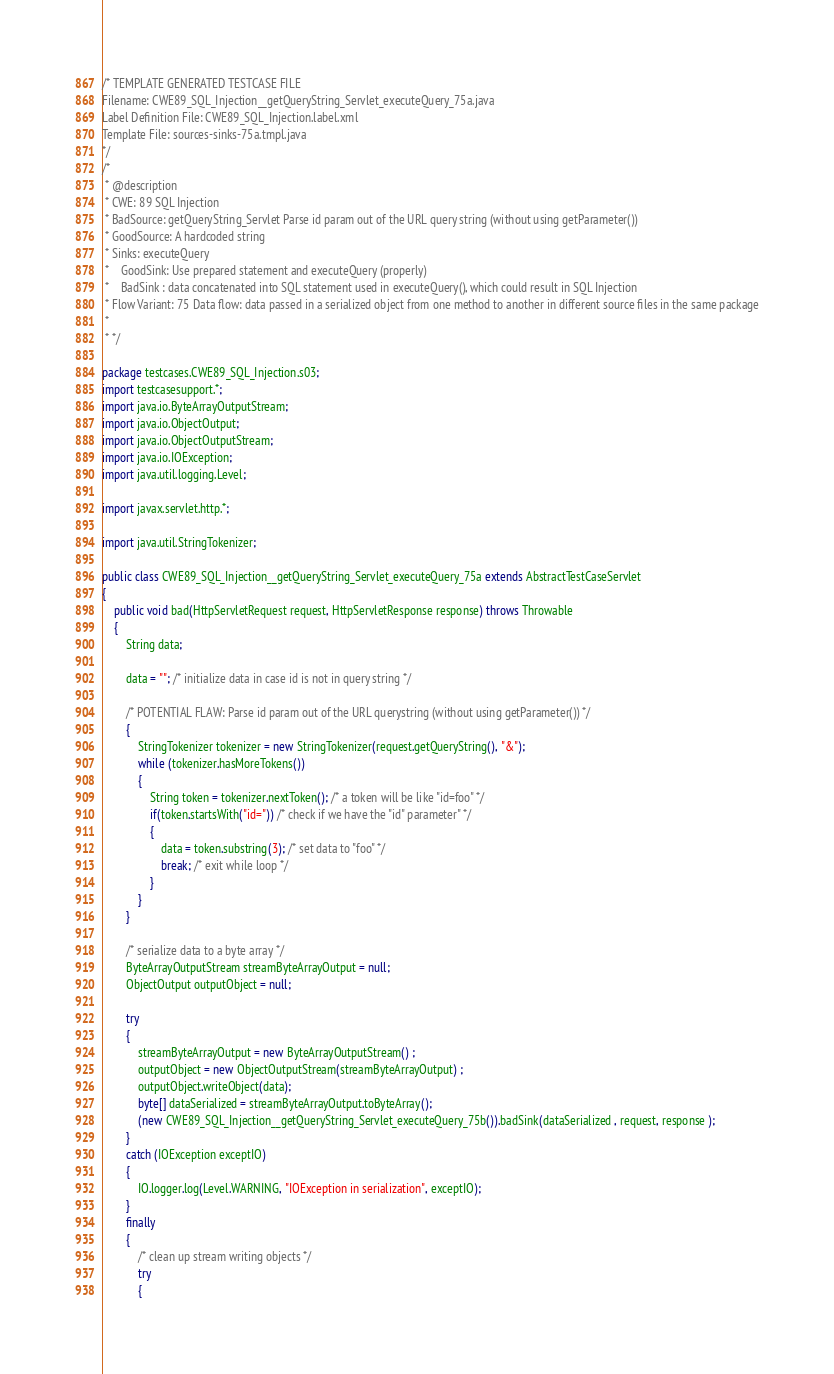Convert code to text. <code><loc_0><loc_0><loc_500><loc_500><_Java_>/* TEMPLATE GENERATED TESTCASE FILE
Filename: CWE89_SQL_Injection__getQueryString_Servlet_executeQuery_75a.java
Label Definition File: CWE89_SQL_Injection.label.xml
Template File: sources-sinks-75a.tmpl.java
*/
/*
 * @description
 * CWE: 89 SQL Injection
 * BadSource: getQueryString_Servlet Parse id param out of the URL query string (without using getParameter())
 * GoodSource: A hardcoded string
 * Sinks: executeQuery
 *    GoodSink: Use prepared statement and executeQuery (properly)
 *    BadSink : data concatenated into SQL statement used in executeQuery(), which could result in SQL Injection
 * Flow Variant: 75 Data flow: data passed in a serialized object from one method to another in different source files in the same package
 *
 * */

package testcases.CWE89_SQL_Injection.s03;
import testcasesupport.*;
import java.io.ByteArrayOutputStream;
import java.io.ObjectOutput;
import java.io.ObjectOutputStream;
import java.io.IOException;
import java.util.logging.Level;

import javax.servlet.http.*;

import java.util.StringTokenizer;

public class CWE89_SQL_Injection__getQueryString_Servlet_executeQuery_75a extends AbstractTestCaseServlet
{
    public void bad(HttpServletRequest request, HttpServletResponse response) throws Throwable
    {
        String data;

        data = ""; /* initialize data in case id is not in query string */

        /* POTENTIAL FLAW: Parse id param out of the URL querystring (without using getParameter()) */
        {
            StringTokenizer tokenizer = new StringTokenizer(request.getQueryString(), "&");
            while (tokenizer.hasMoreTokens())
            {
                String token = tokenizer.nextToken(); /* a token will be like "id=foo" */
                if(token.startsWith("id=")) /* check if we have the "id" parameter" */
                {
                    data = token.substring(3); /* set data to "foo" */
                    break; /* exit while loop */
                }
            }
        }

        /* serialize data to a byte array */
        ByteArrayOutputStream streamByteArrayOutput = null;
        ObjectOutput outputObject = null;

        try
        {
            streamByteArrayOutput = new ByteArrayOutputStream() ;
            outputObject = new ObjectOutputStream(streamByteArrayOutput) ;
            outputObject.writeObject(data);
            byte[] dataSerialized = streamByteArrayOutput.toByteArray();
            (new CWE89_SQL_Injection__getQueryString_Servlet_executeQuery_75b()).badSink(dataSerialized , request, response );
        }
        catch (IOException exceptIO)
        {
            IO.logger.log(Level.WARNING, "IOException in serialization", exceptIO);
        }
        finally
        {
            /* clean up stream writing objects */
            try
            {</code> 